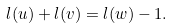<formula> <loc_0><loc_0><loc_500><loc_500>l ( u ) + l ( v ) = l ( w ) - 1 .</formula> 